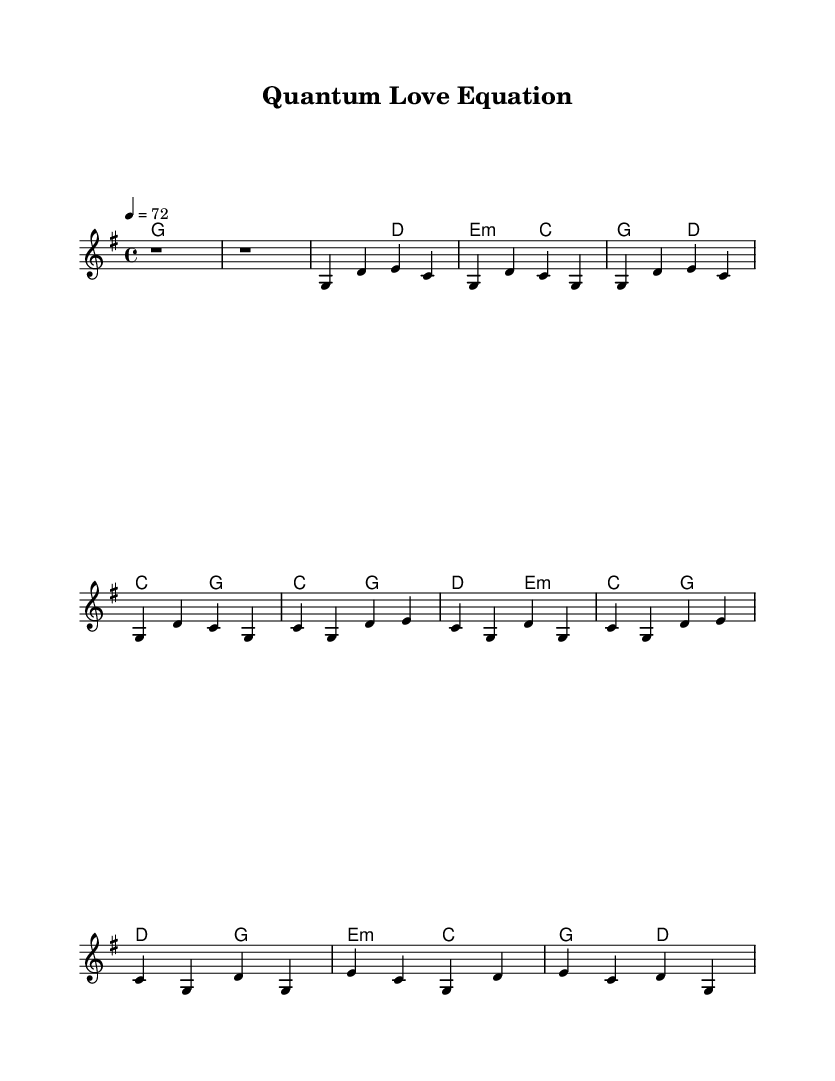What is the key signature of this music? The key signature is G major, which has one sharp (F♯). This is indicated at the beginning of the sheet music by the key signature symbol.
Answer: G major What is the time signature of this music? The time signature is 4/4, which means there are four beats in each measure. This is shown at the beginning of the piece on the staff.
Answer: 4/4 What is the tempo marking for this piece? The tempo marking is 72 beats per minute, indicated by "4 = 72". This tells the performer the speed at which to play the music.
Answer: 72 How many measures are in the verse? The verse consists of 4 measures, with each line specifically showing 2 measures of music (totaling 4 for the verse section).
Answer: 4 Which chord is played in the chorus on the first measure? The first measure of the chorus shows the C major chord, indicated by the chord symbol "C" above the staff.
Answer: C What is the relationship between the chorus and the verse in this song structure? The chorus contrasts the verse by using different melodic and harmonic progressions, showcasing the song's overall dynamic and emotional build-up. This is a common feature in country rock to highlight thematic changes, often evident through repeated phrases with varied intensity.
Answer: Contrast What is the main theme of this ballad based on the title? The title "Quantum Love Equation" suggests themes around love intertwined with scientific discovery and innovation, characteristic of contemporary country rock narratives that blend emotional and intellectual elements.
Answer: Love and science 